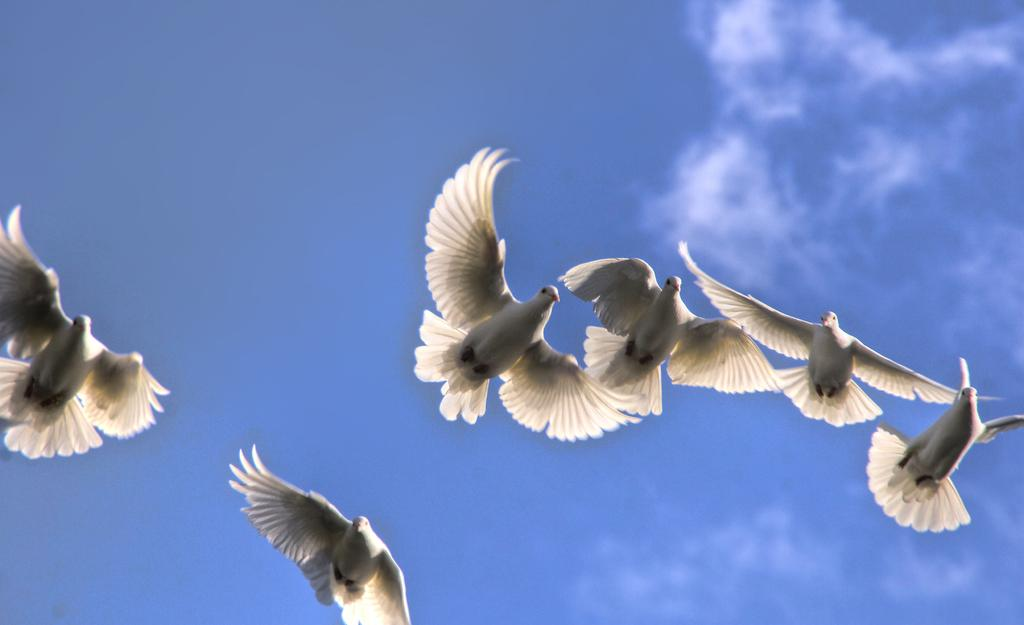Where was the image taken? The image was clicked outside. What can be seen flying in the air in the image? There is a group of pigeons flying in the air in the image. What is visible in the background of the image? The sky is visible in the background of the image. What can be observed in the sky in the image? There are clouds in the sky in the image. Can you see a board with a turkey on it in the image? No, there is no board or turkey present in the image. Is there a dog visible in the image? No, there is no dog visible in the image. 